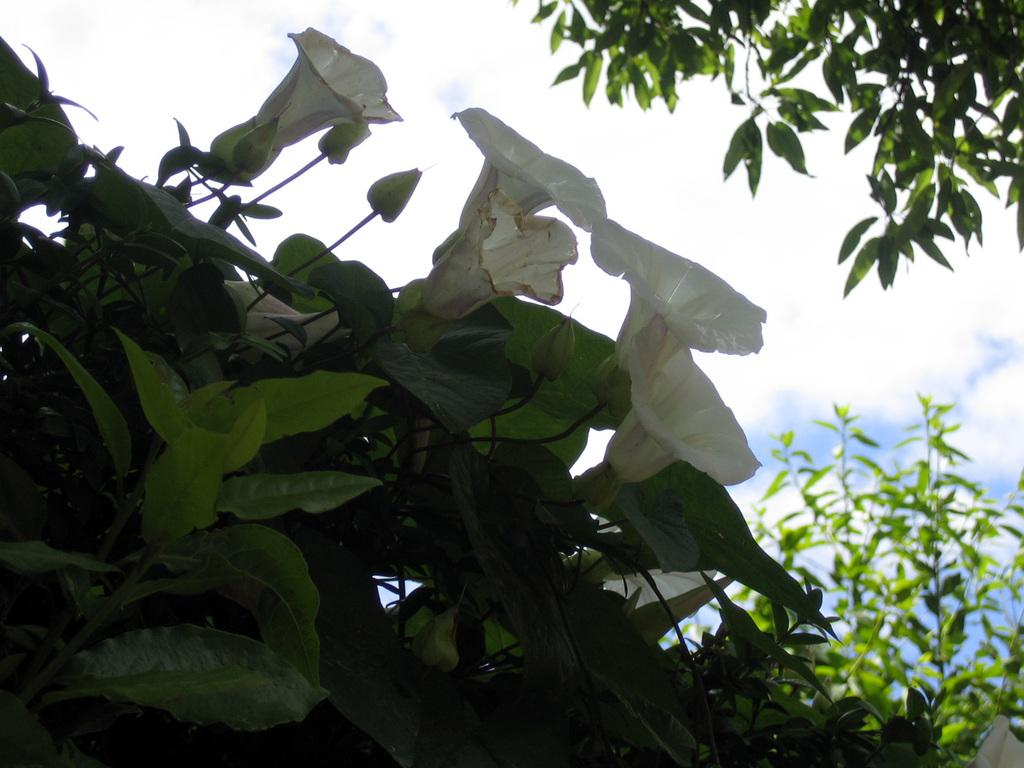What types of living organisms can be seen in the image? Plants and flowers are visible in the image. Can you describe the natural setting visible in the image? The natural setting includes plants and flowers, and the sky is visible in the background of the image. What type of flesh can be seen on the skate in the image? There is no skate or flesh present in the image; it features plants and flowers. 